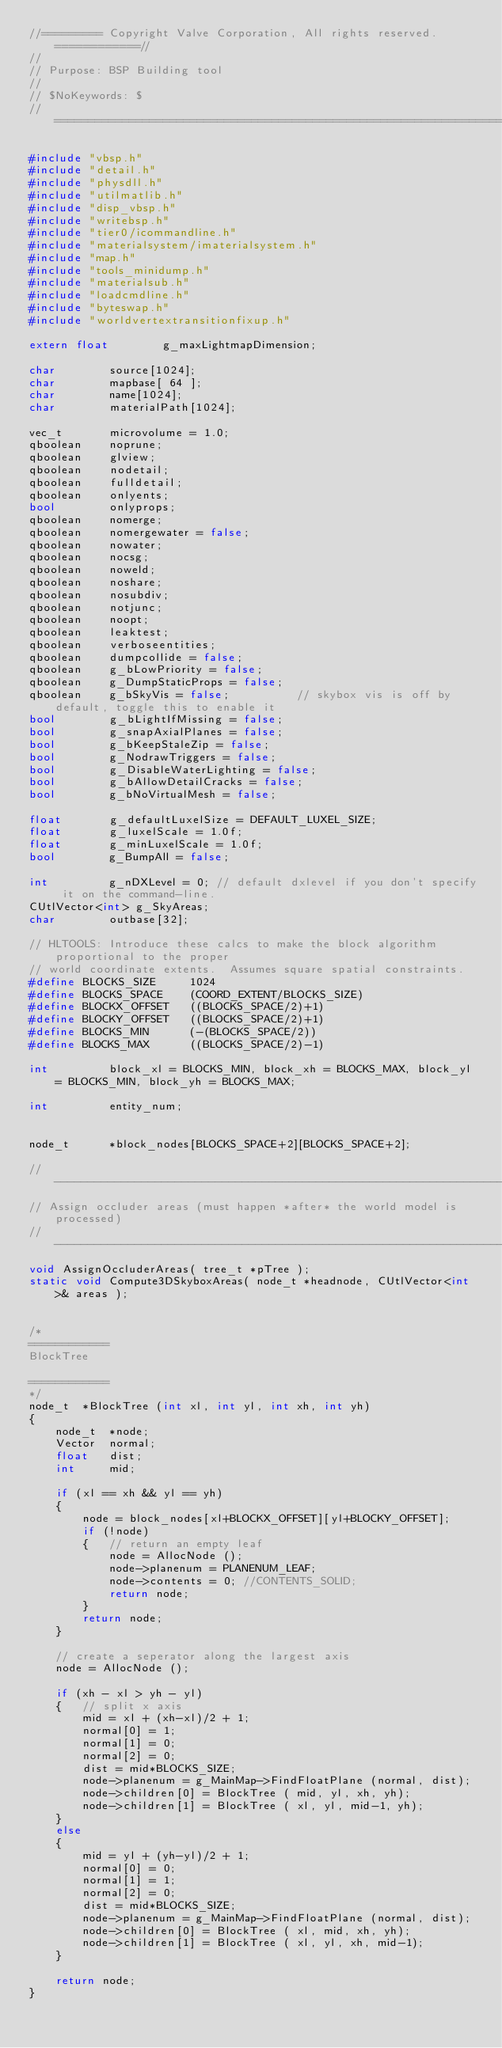Convert code to text. <code><loc_0><loc_0><loc_500><loc_500><_C++_>//========= Copyright Valve Corporation, All rights reserved. ============//
//
// Purpose: BSP Building tool
//
// $NoKeywords: $
//=============================================================================//

#include "vbsp.h"
#include "detail.h"
#include "physdll.h"
#include "utilmatlib.h"
#include "disp_vbsp.h"
#include "writebsp.h"
#include "tier0/icommandline.h"
#include "materialsystem/imaterialsystem.h"
#include "map.h"
#include "tools_minidump.h"
#include "materialsub.h"
#include "loadcmdline.h"
#include "byteswap.h"
#include "worldvertextransitionfixup.h"

extern float		g_maxLightmapDimension;

char		source[1024];
char		mapbase[ 64 ];
char		name[1024];
char		materialPath[1024];

vec_t		microvolume = 1.0;
qboolean	noprune;
qboolean	glview;
qboolean	nodetail;
qboolean	fulldetail;
qboolean	onlyents;
bool		onlyprops;
qboolean	nomerge;
qboolean	nomergewater = false;
qboolean	nowater;
qboolean	nocsg;
qboolean	noweld;
qboolean	noshare;
qboolean	nosubdiv;
qboolean	notjunc;
qboolean	noopt;
qboolean	leaktest;
qboolean	verboseentities;
qboolean	dumpcollide = false;
qboolean	g_bLowPriority = false;
qboolean	g_DumpStaticProps = false;
qboolean	g_bSkyVis = false;			// skybox vis is off by default, toggle this to enable it
bool		g_bLightIfMissing = false;
bool		g_snapAxialPlanes = false;
bool		g_bKeepStaleZip = false;
bool		g_NodrawTriggers = false;
bool		g_DisableWaterLighting = false;
bool		g_bAllowDetailCracks = false;
bool		g_bNoVirtualMesh = false;

float		g_defaultLuxelSize = DEFAULT_LUXEL_SIZE;
float		g_luxelScale = 1.0f;
float		g_minLuxelScale = 1.0f;
bool		g_BumpAll = false;

int			g_nDXLevel = 0; // default dxlevel if you don't specify it on the command-line.
CUtlVector<int> g_SkyAreas;
char		outbase[32];

// HLTOOLS: Introduce these calcs to make the block algorithm proportional to the proper 
// world coordinate extents.  Assumes square spatial constraints.
#define BLOCKS_SIZE		1024
#define BLOCKS_SPACE	(COORD_EXTENT/BLOCKS_SIZE)
#define BLOCKX_OFFSET	((BLOCKS_SPACE/2)+1)
#define BLOCKY_OFFSET	((BLOCKS_SPACE/2)+1)
#define BLOCKS_MIN		(-(BLOCKS_SPACE/2))
#define BLOCKS_MAX		((BLOCKS_SPACE/2)-1)

int			block_xl = BLOCKS_MIN, block_xh = BLOCKS_MAX, block_yl = BLOCKS_MIN, block_yh = BLOCKS_MAX;

int			entity_num;


node_t		*block_nodes[BLOCKS_SPACE+2][BLOCKS_SPACE+2];

//-----------------------------------------------------------------------------
// Assign occluder areas (must happen *after* the world model is processed)
//-----------------------------------------------------------------------------
void AssignOccluderAreas( tree_t *pTree );
static void Compute3DSkyboxAreas( node_t *headnode, CUtlVector<int>& areas );


/*
============
BlockTree

============
*/
node_t	*BlockTree (int xl, int yl, int xh, int yh)
{
	node_t	*node;
	Vector	normal;
	float	dist;
	int		mid;

	if (xl == xh && yl == yh)
	{
		node = block_nodes[xl+BLOCKX_OFFSET][yl+BLOCKY_OFFSET];
		if (!node)
		{	// return an empty leaf
			node = AllocNode ();
			node->planenum = PLANENUM_LEAF;
			node->contents = 0; //CONTENTS_SOLID;
			return node;
		}
		return node;
	}

	// create a seperator along the largest axis
	node = AllocNode ();

	if (xh - xl > yh - yl)
	{	// split x axis
		mid = xl + (xh-xl)/2 + 1;
		normal[0] = 1;
		normal[1] = 0;
		normal[2] = 0;
		dist = mid*BLOCKS_SIZE;
		node->planenum = g_MainMap->FindFloatPlane (normal, dist);
		node->children[0] = BlockTree ( mid, yl, xh, yh);
		node->children[1] = BlockTree ( xl, yl, mid-1, yh);
	}
	else
	{
		mid = yl + (yh-yl)/2 + 1;
		normal[0] = 0;
		normal[1] = 1;
		normal[2] = 0;
		dist = mid*BLOCKS_SIZE;
		node->planenum = g_MainMap->FindFloatPlane (normal, dist);
		node->children[0] = BlockTree ( xl, mid, xh, yh);
		node->children[1] = BlockTree ( xl, yl, xh, mid-1);
	}

	return node;
}</code> 